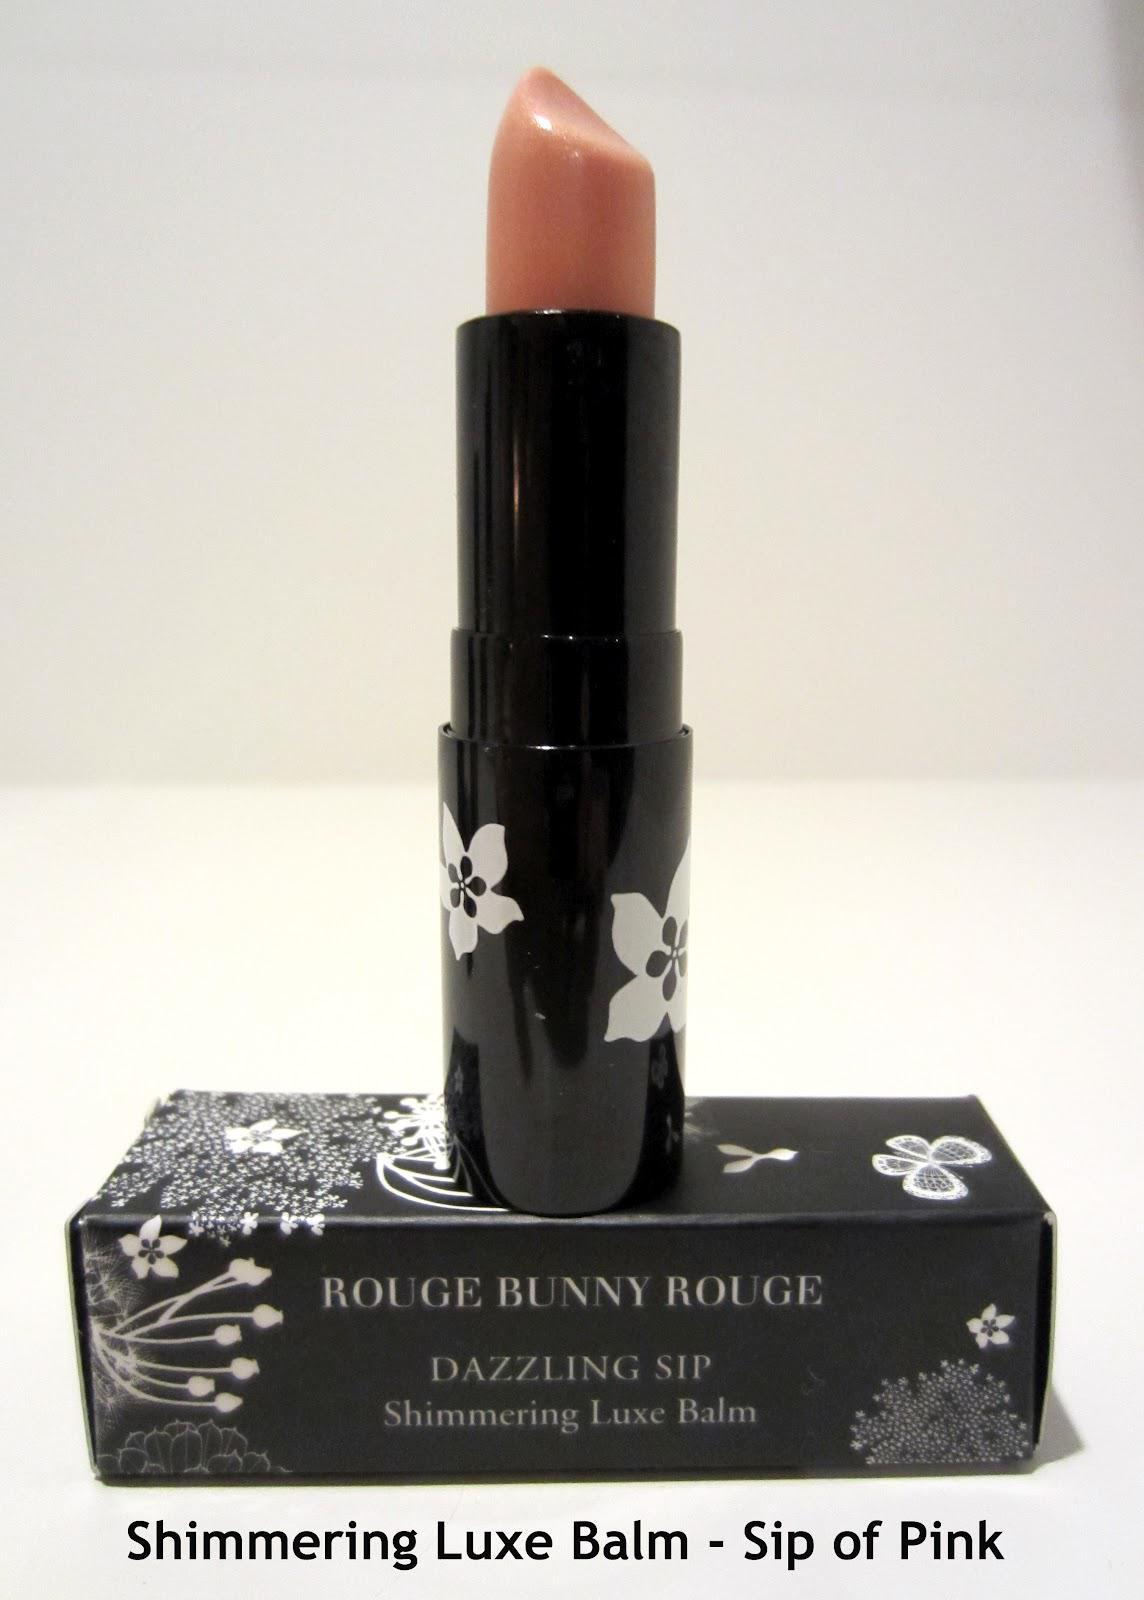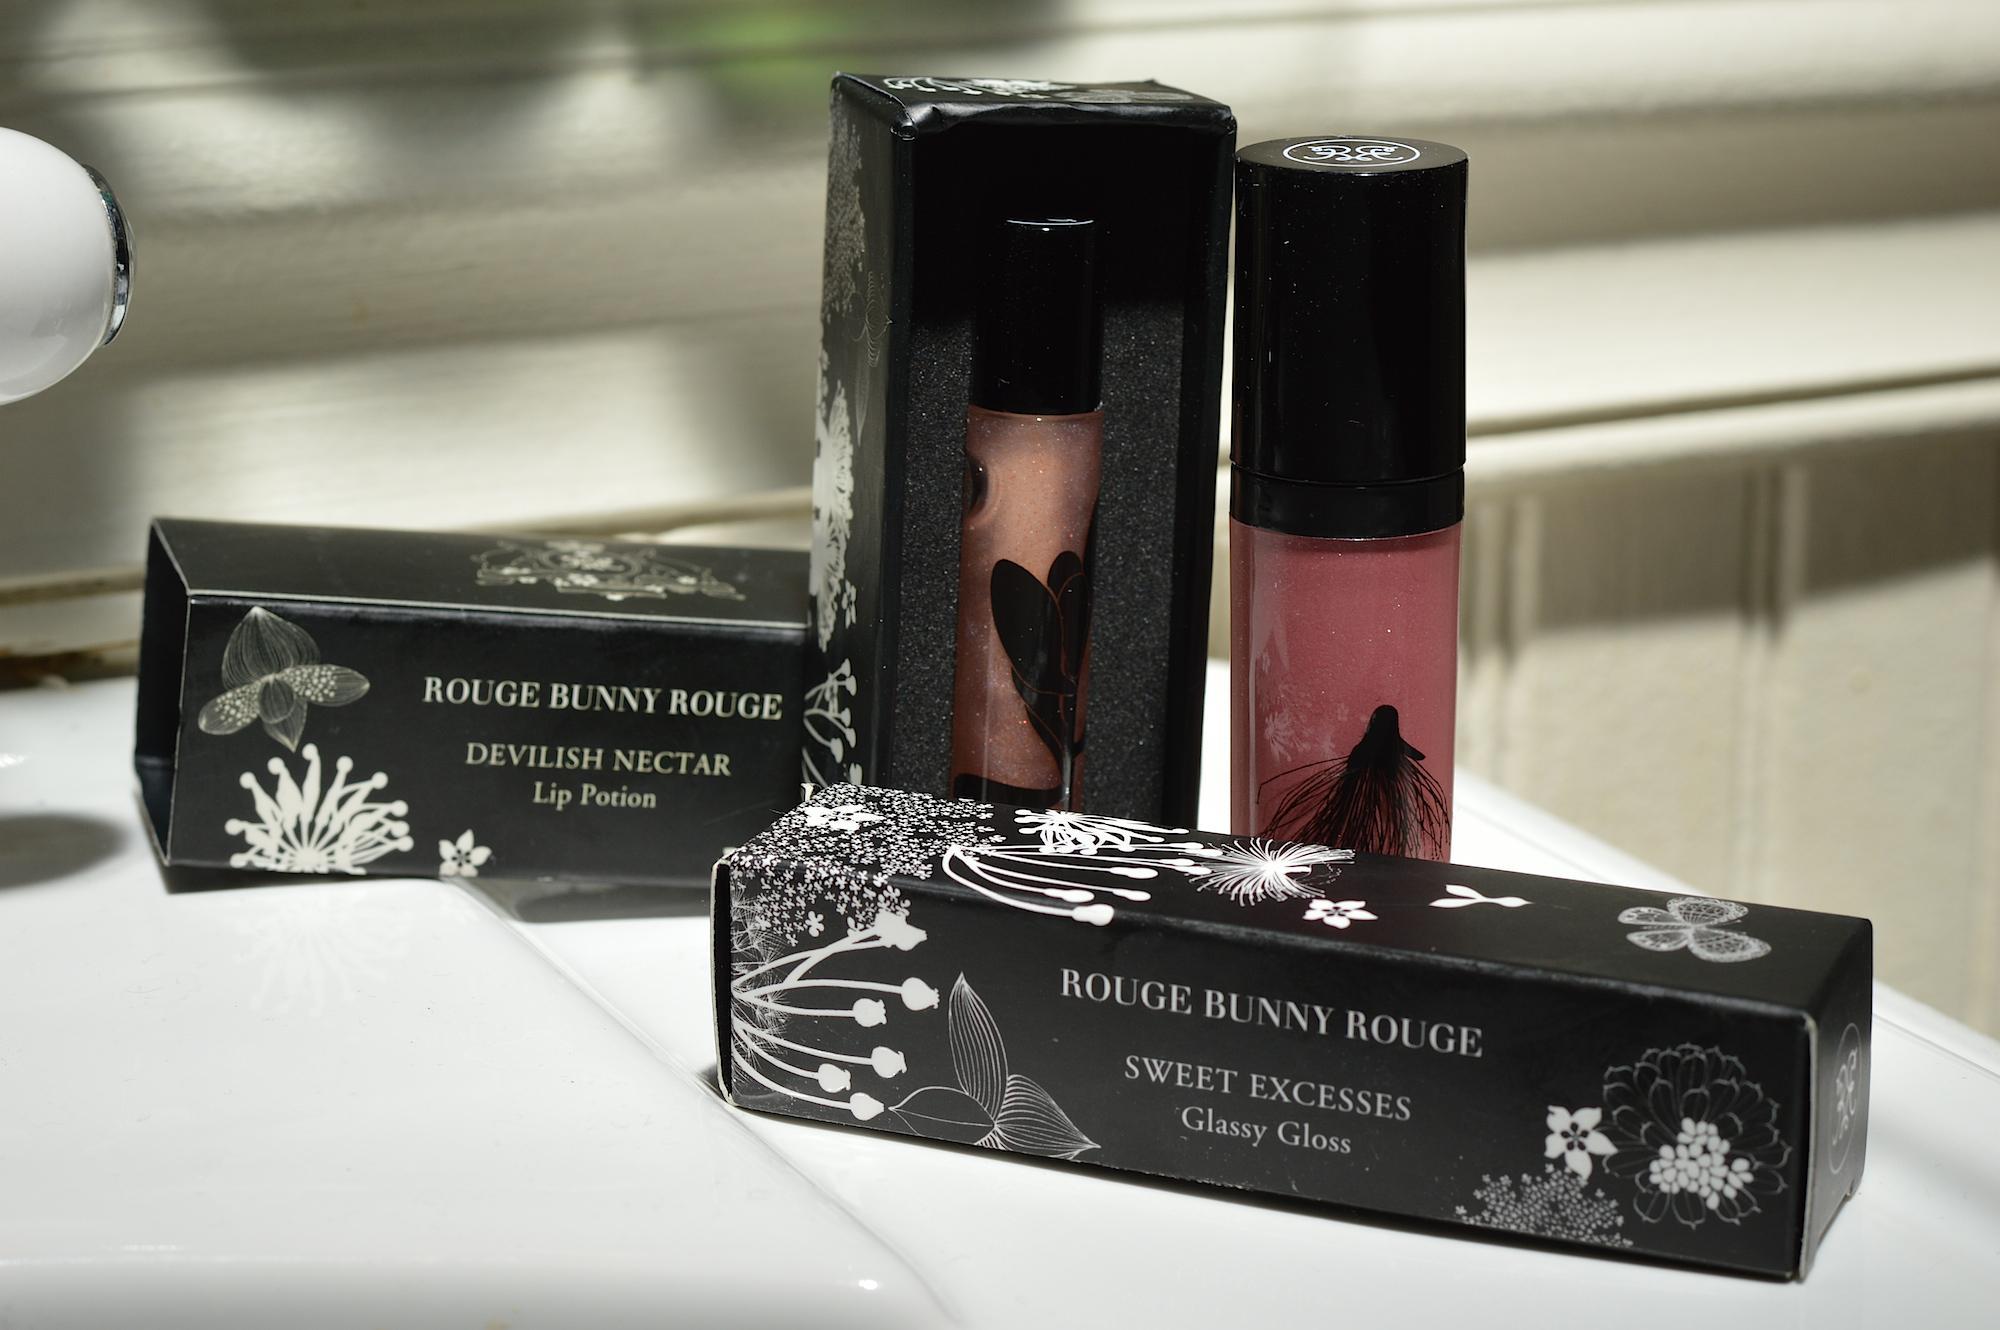The first image is the image on the left, the second image is the image on the right. Assess this claim about the two images: "There are at least eight lip products in total.". Correct or not? Answer yes or no. No. The first image is the image on the left, the second image is the image on the right. Considering the images on both sides, is "In the left image, there is a single tube of makeup, and it has a clear body casing." valid? Answer yes or no. No. 